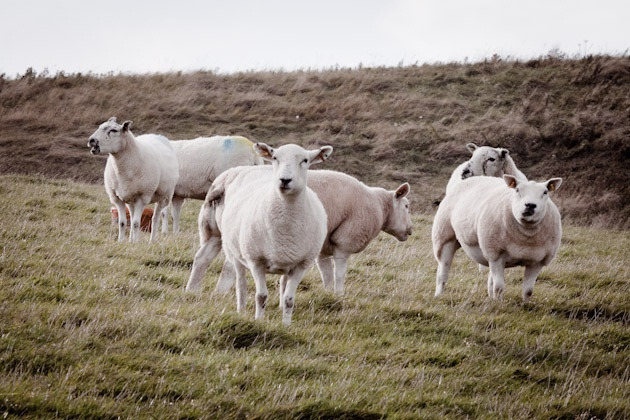Describe the objects in this image and their specific colors. I can see sheep in lightgray, darkgray, and gray tones, sheep in lightgray, darkgray, and gray tones, sheep in lightgray, darkgray, and gray tones, sheep in lightgray, darkgray, and gray tones, and sheep in lightgray, darkgray, and gray tones in this image. 